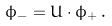Convert formula to latex. <formula><loc_0><loc_0><loc_500><loc_500>\phi _ { - } = U \cdot \phi _ { + } \, .</formula> 